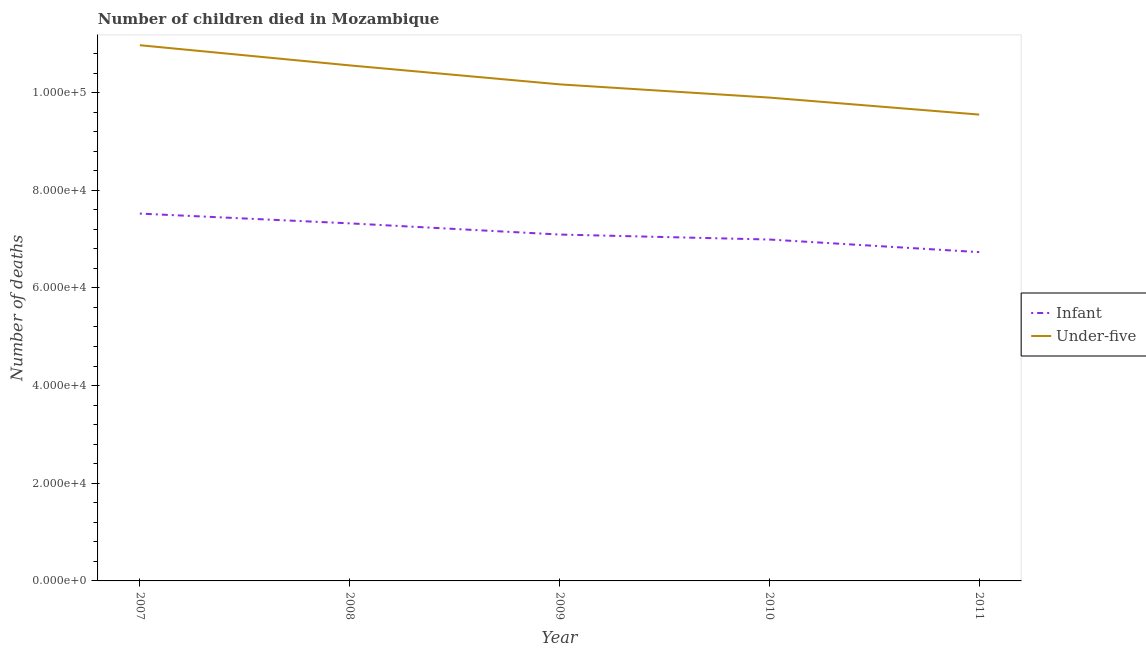How many different coloured lines are there?
Provide a succinct answer. 2. Does the line corresponding to number of under-five deaths intersect with the line corresponding to number of infant deaths?
Keep it short and to the point. No. What is the number of infant deaths in 2007?
Provide a succinct answer. 7.52e+04. Across all years, what is the maximum number of under-five deaths?
Ensure brevity in your answer.  1.10e+05. Across all years, what is the minimum number of under-five deaths?
Your answer should be very brief. 9.55e+04. In which year was the number of infant deaths maximum?
Offer a very short reply. 2007. What is the total number of under-five deaths in the graph?
Provide a succinct answer. 5.11e+05. What is the difference between the number of under-five deaths in 2007 and that in 2009?
Offer a terse response. 8011. What is the difference between the number of infant deaths in 2008 and the number of under-five deaths in 2009?
Your answer should be very brief. -2.85e+04. What is the average number of infant deaths per year?
Your response must be concise. 7.13e+04. In the year 2010, what is the difference between the number of infant deaths and number of under-five deaths?
Offer a very short reply. -2.91e+04. In how many years, is the number of infant deaths greater than 16000?
Give a very brief answer. 5. What is the ratio of the number of infant deaths in 2007 to that in 2009?
Provide a succinct answer. 1.06. Is the number of infant deaths in 2007 less than that in 2010?
Provide a short and direct response. No. What is the difference between the highest and the second highest number of under-five deaths?
Keep it short and to the point. 4130. What is the difference between the highest and the lowest number of infant deaths?
Your response must be concise. 7889. In how many years, is the number of infant deaths greater than the average number of infant deaths taken over all years?
Ensure brevity in your answer.  2. Is the sum of the number of infant deaths in 2010 and 2011 greater than the maximum number of under-five deaths across all years?
Your response must be concise. Yes. Does the number of under-five deaths monotonically increase over the years?
Offer a terse response. No. Is the number of under-five deaths strictly greater than the number of infant deaths over the years?
Your response must be concise. Yes. Is the number of infant deaths strictly less than the number of under-five deaths over the years?
Provide a short and direct response. Yes. How many lines are there?
Your answer should be compact. 2. Does the graph contain any zero values?
Provide a short and direct response. No. Does the graph contain grids?
Your answer should be very brief. No. How many legend labels are there?
Provide a succinct answer. 2. What is the title of the graph?
Provide a short and direct response. Number of children died in Mozambique. Does "US$" appear as one of the legend labels in the graph?
Your answer should be very brief. No. What is the label or title of the X-axis?
Provide a succinct answer. Year. What is the label or title of the Y-axis?
Offer a terse response. Number of deaths. What is the Number of deaths in Infant in 2007?
Provide a succinct answer. 7.52e+04. What is the Number of deaths in Under-five in 2007?
Provide a short and direct response. 1.10e+05. What is the Number of deaths in Infant in 2008?
Keep it short and to the point. 7.32e+04. What is the Number of deaths of Under-five in 2008?
Offer a very short reply. 1.06e+05. What is the Number of deaths in Infant in 2009?
Your answer should be compact. 7.09e+04. What is the Number of deaths in Under-five in 2009?
Offer a very short reply. 1.02e+05. What is the Number of deaths of Infant in 2010?
Give a very brief answer. 6.99e+04. What is the Number of deaths in Under-five in 2010?
Provide a short and direct response. 9.90e+04. What is the Number of deaths of Infant in 2011?
Your answer should be very brief. 6.73e+04. What is the Number of deaths in Under-five in 2011?
Give a very brief answer. 9.55e+04. Across all years, what is the maximum Number of deaths of Infant?
Ensure brevity in your answer.  7.52e+04. Across all years, what is the maximum Number of deaths in Under-five?
Provide a succinct answer. 1.10e+05. Across all years, what is the minimum Number of deaths of Infant?
Offer a very short reply. 6.73e+04. Across all years, what is the minimum Number of deaths of Under-five?
Your response must be concise. 9.55e+04. What is the total Number of deaths of Infant in the graph?
Keep it short and to the point. 3.57e+05. What is the total Number of deaths in Under-five in the graph?
Your response must be concise. 5.11e+05. What is the difference between the Number of deaths in Infant in 2007 and that in 2008?
Ensure brevity in your answer.  1998. What is the difference between the Number of deaths in Under-five in 2007 and that in 2008?
Your answer should be compact. 4130. What is the difference between the Number of deaths in Infant in 2007 and that in 2009?
Offer a terse response. 4286. What is the difference between the Number of deaths in Under-five in 2007 and that in 2009?
Provide a short and direct response. 8011. What is the difference between the Number of deaths of Infant in 2007 and that in 2010?
Make the answer very short. 5307. What is the difference between the Number of deaths of Under-five in 2007 and that in 2010?
Provide a short and direct response. 1.07e+04. What is the difference between the Number of deaths of Infant in 2007 and that in 2011?
Make the answer very short. 7889. What is the difference between the Number of deaths of Under-five in 2007 and that in 2011?
Ensure brevity in your answer.  1.42e+04. What is the difference between the Number of deaths of Infant in 2008 and that in 2009?
Your response must be concise. 2288. What is the difference between the Number of deaths of Under-five in 2008 and that in 2009?
Offer a terse response. 3881. What is the difference between the Number of deaths in Infant in 2008 and that in 2010?
Your answer should be compact. 3309. What is the difference between the Number of deaths of Under-five in 2008 and that in 2010?
Your answer should be compact. 6592. What is the difference between the Number of deaths in Infant in 2008 and that in 2011?
Keep it short and to the point. 5891. What is the difference between the Number of deaths in Under-five in 2008 and that in 2011?
Keep it short and to the point. 1.01e+04. What is the difference between the Number of deaths of Infant in 2009 and that in 2010?
Your answer should be compact. 1021. What is the difference between the Number of deaths of Under-five in 2009 and that in 2010?
Ensure brevity in your answer.  2711. What is the difference between the Number of deaths of Infant in 2009 and that in 2011?
Give a very brief answer. 3603. What is the difference between the Number of deaths of Under-five in 2009 and that in 2011?
Your answer should be very brief. 6195. What is the difference between the Number of deaths of Infant in 2010 and that in 2011?
Your answer should be very brief. 2582. What is the difference between the Number of deaths in Under-five in 2010 and that in 2011?
Keep it short and to the point. 3484. What is the difference between the Number of deaths of Infant in 2007 and the Number of deaths of Under-five in 2008?
Offer a very short reply. -3.04e+04. What is the difference between the Number of deaths of Infant in 2007 and the Number of deaths of Under-five in 2009?
Your answer should be very brief. -2.65e+04. What is the difference between the Number of deaths in Infant in 2007 and the Number of deaths in Under-five in 2010?
Your answer should be very brief. -2.38e+04. What is the difference between the Number of deaths of Infant in 2007 and the Number of deaths of Under-five in 2011?
Provide a succinct answer. -2.03e+04. What is the difference between the Number of deaths in Infant in 2008 and the Number of deaths in Under-five in 2009?
Your answer should be very brief. -2.85e+04. What is the difference between the Number of deaths of Infant in 2008 and the Number of deaths of Under-five in 2010?
Your answer should be compact. -2.58e+04. What is the difference between the Number of deaths of Infant in 2008 and the Number of deaths of Under-five in 2011?
Give a very brief answer. -2.23e+04. What is the difference between the Number of deaths of Infant in 2009 and the Number of deaths of Under-five in 2010?
Your answer should be very brief. -2.80e+04. What is the difference between the Number of deaths in Infant in 2009 and the Number of deaths in Under-five in 2011?
Your answer should be very brief. -2.46e+04. What is the difference between the Number of deaths of Infant in 2010 and the Number of deaths of Under-five in 2011?
Your answer should be very brief. -2.56e+04. What is the average Number of deaths of Infant per year?
Offer a terse response. 7.13e+04. What is the average Number of deaths of Under-five per year?
Your response must be concise. 1.02e+05. In the year 2007, what is the difference between the Number of deaths in Infant and Number of deaths in Under-five?
Provide a short and direct response. -3.45e+04. In the year 2008, what is the difference between the Number of deaths in Infant and Number of deaths in Under-five?
Give a very brief answer. -3.24e+04. In the year 2009, what is the difference between the Number of deaths of Infant and Number of deaths of Under-five?
Your response must be concise. -3.08e+04. In the year 2010, what is the difference between the Number of deaths in Infant and Number of deaths in Under-five?
Provide a short and direct response. -2.91e+04. In the year 2011, what is the difference between the Number of deaths in Infant and Number of deaths in Under-five?
Make the answer very short. -2.82e+04. What is the ratio of the Number of deaths in Infant in 2007 to that in 2008?
Your response must be concise. 1.03. What is the ratio of the Number of deaths in Under-five in 2007 to that in 2008?
Your answer should be very brief. 1.04. What is the ratio of the Number of deaths of Infant in 2007 to that in 2009?
Provide a short and direct response. 1.06. What is the ratio of the Number of deaths in Under-five in 2007 to that in 2009?
Offer a very short reply. 1.08. What is the ratio of the Number of deaths of Infant in 2007 to that in 2010?
Offer a very short reply. 1.08. What is the ratio of the Number of deaths in Under-five in 2007 to that in 2010?
Provide a short and direct response. 1.11. What is the ratio of the Number of deaths of Infant in 2007 to that in 2011?
Keep it short and to the point. 1.12. What is the ratio of the Number of deaths of Under-five in 2007 to that in 2011?
Provide a short and direct response. 1.15. What is the ratio of the Number of deaths of Infant in 2008 to that in 2009?
Provide a short and direct response. 1.03. What is the ratio of the Number of deaths in Under-five in 2008 to that in 2009?
Your answer should be compact. 1.04. What is the ratio of the Number of deaths in Infant in 2008 to that in 2010?
Make the answer very short. 1.05. What is the ratio of the Number of deaths in Under-five in 2008 to that in 2010?
Provide a short and direct response. 1.07. What is the ratio of the Number of deaths of Infant in 2008 to that in 2011?
Offer a very short reply. 1.09. What is the ratio of the Number of deaths of Under-five in 2008 to that in 2011?
Make the answer very short. 1.11. What is the ratio of the Number of deaths of Infant in 2009 to that in 2010?
Offer a terse response. 1.01. What is the ratio of the Number of deaths in Under-five in 2009 to that in 2010?
Offer a very short reply. 1.03. What is the ratio of the Number of deaths in Infant in 2009 to that in 2011?
Your answer should be very brief. 1.05. What is the ratio of the Number of deaths of Under-five in 2009 to that in 2011?
Ensure brevity in your answer.  1.06. What is the ratio of the Number of deaths in Infant in 2010 to that in 2011?
Ensure brevity in your answer.  1.04. What is the ratio of the Number of deaths in Under-five in 2010 to that in 2011?
Your answer should be compact. 1.04. What is the difference between the highest and the second highest Number of deaths in Infant?
Make the answer very short. 1998. What is the difference between the highest and the second highest Number of deaths in Under-five?
Your response must be concise. 4130. What is the difference between the highest and the lowest Number of deaths in Infant?
Provide a succinct answer. 7889. What is the difference between the highest and the lowest Number of deaths in Under-five?
Offer a very short reply. 1.42e+04. 